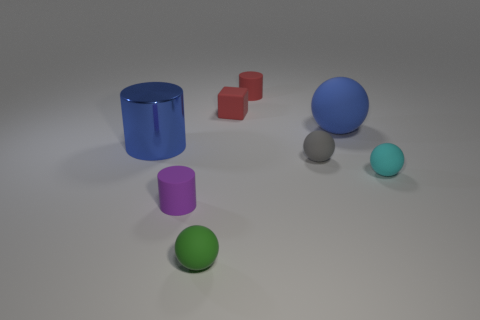Add 1 small red matte cubes. How many objects exist? 9 Subtract all blocks. How many objects are left? 7 Subtract 0 cyan cylinders. How many objects are left? 8 Subtract all cyan rubber objects. Subtract all small matte spheres. How many objects are left? 4 Add 1 blocks. How many blocks are left? 2 Add 7 tiny brown blocks. How many tiny brown blocks exist? 7 